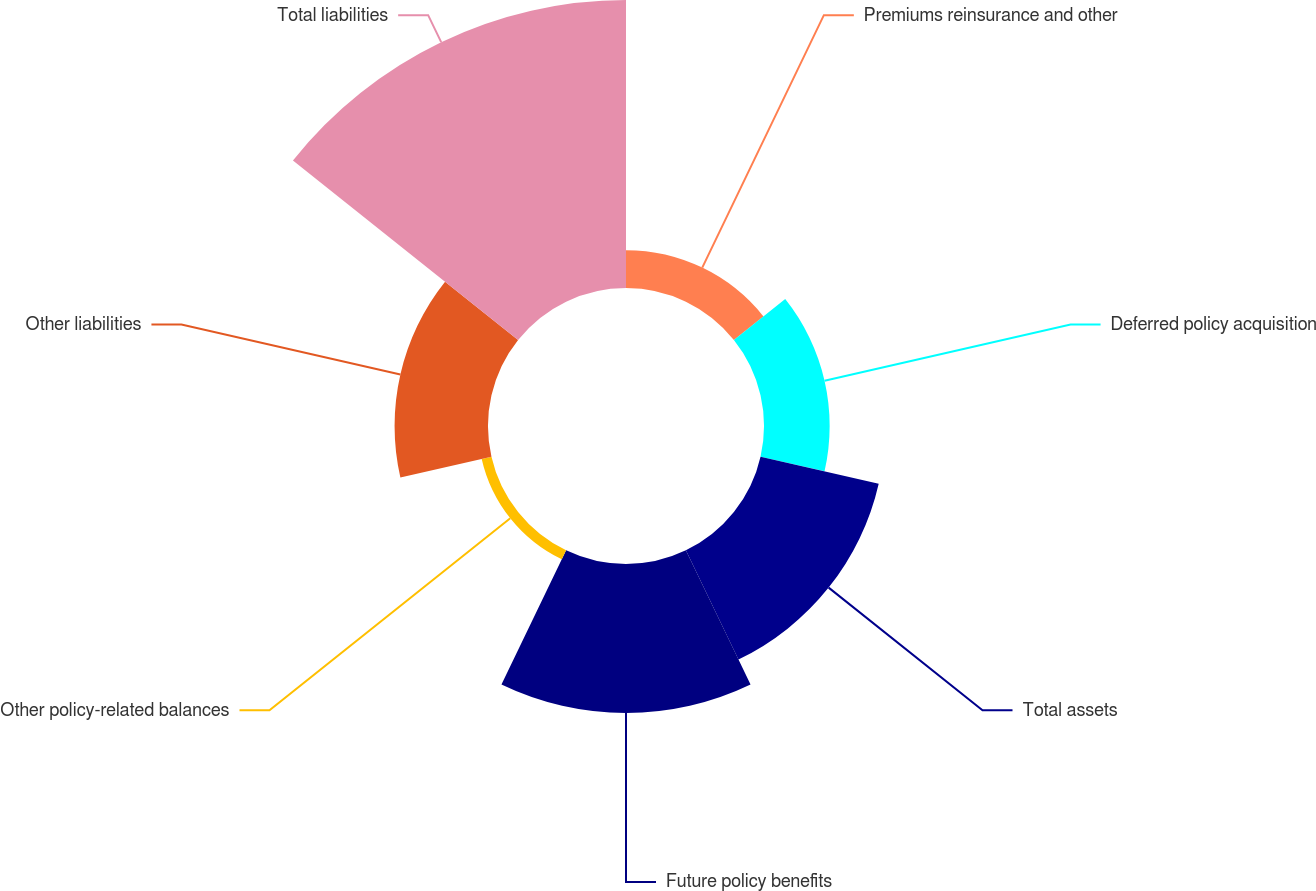<chart> <loc_0><loc_0><loc_500><loc_500><pie_chart><fcel>Premiums reinsurance and other<fcel>Deferred policy acquisition<fcel>Total assets<fcel>Future policy benefits<fcel>Other policy-related balances<fcel>Other liabilities<fcel>Total liabilities<nl><fcel>4.94%<fcel>8.58%<fcel>15.84%<fcel>19.48%<fcel>1.31%<fcel>12.21%<fcel>37.64%<nl></chart> 